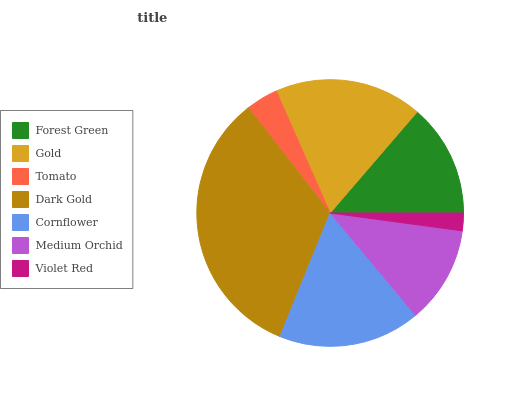Is Violet Red the minimum?
Answer yes or no. Yes. Is Dark Gold the maximum?
Answer yes or no. Yes. Is Gold the minimum?
Answer yes or no. No. Is Gold the maximum?
Answer yes or no. No. Is Gold greater than Forest Green?
Answer yes or no. Yes. Is Forest Green less than Gold?
Answer yes or no. Yes. Is Forest Green greater than Gold?
Answer yes or no. No. Is Gold less than Forest Green?
Answer yes or no. No. Is Forest Green the high median?
Answer yes or no. Yes. Is Forest Green the low median?
Answer yes or no. Yes. Is Medium Orchid the high median?
Answer yes or no. No. Is Violet Red the low median?
Answer yes or no. No. 